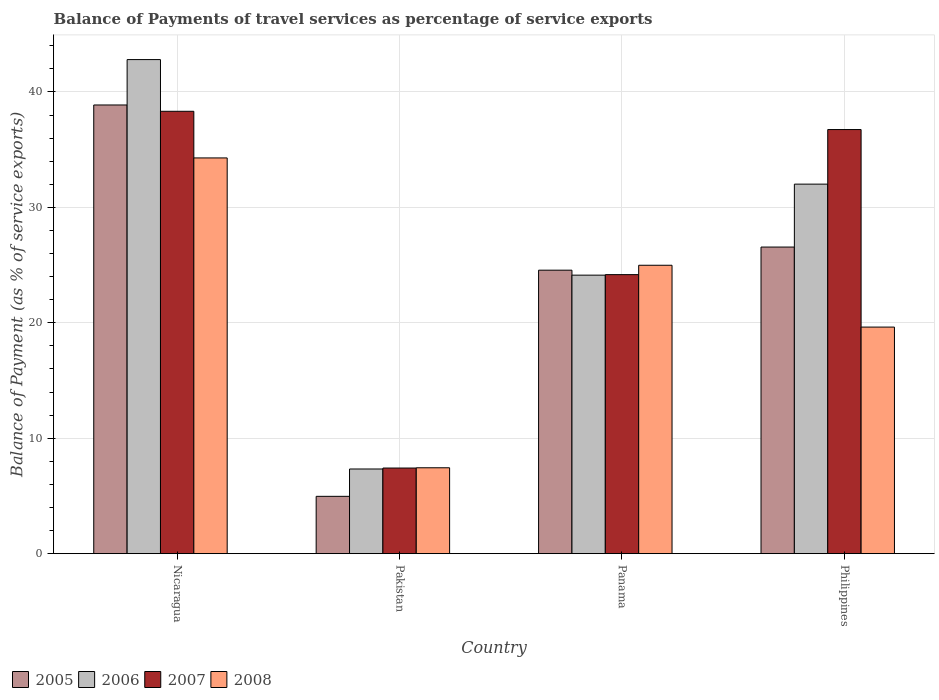How many groups of bars are there?
Keep it short and to the point. 4. Are the number of bars per tick equal to the number of legend labels?
Your answer should be very brief. Yes. Are the number of bars on each tick of the X-axis equal?
Your response must be concise. Yes. How many bars are there on the 4th tick from the right?
Provide a short and direct response. 4. What is the label of the 1st group of bars from the left?
Make the answer very short. Nicaragua. In how many cases, is the number of bars for a given country not equal to the number of legend labels?
Give a very brief answer. 0. What is the balance of payments of travel services in 2007 in Panama?
Offer a terse response. 24.18. Across all countries, what is the maximum balance of payments of travel services in 2005?
Provide a short and direct response. 38.87. Across all countries, what is the minimum balance of payments of travel services in 2005?
Make the answer very short. 4.97. In which country was the balance of payments of travel services in 2005 maximum?
Your answer should be compact. Nicaragua. In which country was the balance of payments of travel services in 2008 minimum?
Provide a short and direct response. Pakistan. What is the total balance of payments of travel services in 2007 in the graph?
Ensure brevity in your answer.  106.66. What is the difference between the balance of payments of travel services in 2008 in Nicaragua and that in Pakistan?
Give a very brief answer. 26.85. What is the difference between the balance of payments of travel services in 2006 in Pakistan and the balance of payments of travel services in 2008 in Philippines?
Keep it short and to the point. -12.29. What is the average balance of payments of travel services in 2008 per country?
Ensure brevity in your answer.  21.59. What is the difference between the balance of payments of travel services of/in 2005 and balance of payments of travel services of/in 2006 in Nicaragua?
Make the answer very short. -3.93. In how many countries, is the balance of payments of travel services in 2006 greater than 34 %?
Ensure brevity in your answer.  1. What is the ratio of the balance of payments of travel services in 2008 in Panama to that in Philippines?
Give a very brief answer. 1.27. Is the difference between the balance of payments of travel services in 2005 in Nicaragua and Pakistan greater than the difference between the balance of payments of travel services in 2006 in Nicaragua and Pakistan?
Make the answer very short. No. What is the difference between the highest and the second highest balance of payments of travel services in 2005?
Make the answer very short. -2. What is the difference between the highest and the lowest balance of payments of travel services in 2005?
Provide a short and direct response. 33.91. Is the sum of the balance of payments of travel services in 2007 in Nicaragua and Philippines greater than the maximum balance of payments of travel services in 2008 across all countries?
Your response must be concise. Yes. What does the 1st bar from the left in Nicaragua represents?
Your answer should be compact. 2005. What does the 3rd bar from the right in Nicaragua represents?
Your answer should be compact. 2006. Are all the bars in the graph horizontal?
Make the answer very short. No. How many countries are there in the graph?
Keep it short and to the point. 4. What is the difference between two consecutive major ticks on the Y-axis?
Provide a succinct answer. 10. Are the values on the major ticks of Y-axis written in scientific E-notation?
Offer a terse response. No. Does the graph contain any zero values?
Provide a short and direct response. No. Where does the legend appear in the graph?
Your response must be concise. Bottom left. How are the legend labels stacked?
Your answer should be very brief. Horizontal. What is the title of the graph?
Provide a succinct answer. Balance of Payments of travel services as percentage of service exports. Does "1974" appear as one of the legend labels in the graph?
Provide a short and direct response. No. What is the label or title of the X-axis?
Give a very brief answer. Country. What is the label or title of the Y-axis?
Provide a succinct answer. Balance of Payment (as % of service exports). What is the Balance of Payment (as % of service exports) of 2005 in Nicaragua?
Give a very brief answer. 38.87. What is the Balance of Payment (as % of service exports) in 2006 in Nicaragua?
Provide a short and direct response. 42.81. What is the Balance of Payment (as % of service exports) of 2007 in Nicaragua?
Your answer should be very brief. 38.33. What is the Balance of Payment (as % of service exports) in 2008 in Nicaragua?
Provide a succinct answer. 34.29. What is the Balance of Payment (as % of service exports) of 2005 in Pakistan?
Your answer should be compact. 4.97. What is the Balance of Payment (as % of service exports) of 2006 in Pakistan?
Your response must be concise. 7.34. What is the Balance of Payment (as % of service exports) in 2007 in Pakistan?
Your answer should be compact. 7.42. What is the Balance of Payment (as % of service exports) in 2008 in Pakistan?
Provide a succinct answer. 7.44. What is the Balance of Payment (as % of service exports) in 2005 in Panama?
Your response must be concise. 24.56. What is the Balance of Payment (as % of service exports) in 2006 in Panama?
Your answer should be compact. 24.13. What is the Balance of Payment (as % of service exports) of 2007 in Panama?
Provide a short and direct response. 24.18. What is the Balance of Payment (as % of service exports) of 2008 in Panama?
Ensure brevity in your answer.  24.99. What is the Balance of Payment (as % of service exports) in 2005 in Philippines?
Offer a terse response. 26.56. What is the Balance of Payment (as % of service exports) of 2006 in Philippines?
Offer a terse response. 32.02. What is the Balance of Payment (as % of service exports) of 2007 in Philippines?
Your answer should be compact. 36.74. What is the Balance of Payment (as % of service exports) in 2008 in Philippines?
Make the answer very short. 19.63. Across all countries, what is the maximum Balance of Payment (as % of service exports) in 2005?
Offer a very short reply. 38.87. Across all countries, what is the maximum Balance of Payment (as % of service exports) of 2006?
Offer a terse response. 42.81. Across all countries, what is the maximum Balance of Payment (as % of service exports) in 2007?
Ensure brevity in your answer.  38.33. Across all countries, what is the maximum Balance of Payment (as % of service exports) of 2008?
Give a very brief answer. 34.29. Across all countries, what is the minimum Balance of Payment (as % of service exports) of 2005?
Your answer should be very brief. 4.97. Across all countries, what is the minimum Balance of Payment (as % of service exports) of 2006?
Your answer should be compact. 7.34. Across all countries, what is the minimum Balance of Payment (as % of service exports) of 2007?
Keep it short and to the point. 7.42. Across all countries, what is the minimum Balance of Payment (as % of service exports) in 2008?
Make the answer very short. 7.44. What is the total Balance of Payment (as % of service exports) of 2005 in the graph?
Your response must be concise. 94.96. What is the total Balance of Payment (as % of service exports) in 2006 in the graph?
Make the answer very short. 106.29. What is the total Balance of Payment (as % of service exports) of 2007 in the graph?
Your response must be concise. 106.66. What is the total Balance of Payment (as % of service exports) of 2008 in the graph?
Offer a terse response. 86.34. What is the difference between the Balance of Payment (as % of service exports) of 2005 in Nicaragua and that in Pakistan?
Provide a short and direct response. 33.91. What is the difference between the Balance of Payment (as % of service exports) of 2006 in Nicaragua and that in Pakistan?
Make the answer very short. 35.47. What is the difference between the Balance of Payment (as % of service exports) of 2007 in Nicaragua and that in Pakistan?
Your answer should be compact. 30.91. What is the difference between the Balance of Payment (as % of service exports) in 2008 in Nicaragua and that in Pakistan?
Your answer should be compact. 26.85. What is the difference between the Balance of Payment (as % of service exports) of 2005 in Nicaragua and that in Panama?
Offer a very short reply. 14.31. What is the difference between the Balance of Payment (as % of service exports) of 2006 in Nicaragua and that in Panama?
Ensure brevity in your answer.  18.68. What is the difference between the Balance of Payment (as % of service exports) in 2007 in Nicaragua and that in Panama?
Ensure brevity in your answer.  14.15. What is the difference between the Balance of Payment (as % of service exports) in 2008 in Nicaragua and that in Panama?
Your answer should be very brief. 9.3. What is the difference between the Balance of Payment (as % of service exports) of 2005 in Nicaragua and that in Philippines?
Your answer should be compact. 12.31. What is the difference between the Balance of Payment (as % of service exports) in 2006 in Nicaragua and that in Philippines?
Provide a succinct answer. 10.79. What is the difference between the Balance of Payment (as % of service exports) of 2007 in Nicaragua and that in Philippines?
Make the answer very short. 1.58. What is the difference between the Balance of Payment (as % of service exports) in 2008 in Nicaragua and that in Philippines?
Offer a very short reply. 14.66. What is the difference between the Balance of Payment (as % of service exports) in 2005 in Pakistan and that in Panama?
Your answer should be very brief. -19.59. What is the difference between the Balance of Payment (as % of service exports) in 2006 in Pakistan and that in Panama?
Your answer should be compact. -16.79. What is the difference between the Balance of Payment (as % of service exports) of 2007 in Pakistan and that in Panama?
Provide a succinct answer. -16.76. What is the difference between the Balance of Payment (as % of service exports) of 2008 in Pakistan and that in Panama?
Provide a succinct answer. -17.55. What is the difference between the Balance of Payment (as % of service exports) of 2005 in Pakistan and that in Philippines?
Keep it short and to the point. -21.6. What is the difference between the Balance of Payment (as % of service exports) in 2006 in Pakistan and that in Philippines?
Your response must be concise. -24.68. What is the difference between the Balance of Payment (as % of service exports) of 2007 in Pakistan and that in Philippines?
Offer a terse response. -29.33. What is the difference between the Balance of Payment (as % of service exports) of 2008 in Pakistan and that in Philippines?
Your answer should be compact. -12.19. What is the difference between the Balance of Payment (as % of service exports) of 2005 in Panama and that in Philippines?
Your answer should be very brief. -2. What is the difference between the Balance of Payment (as % of service exports) in 2006 in Panama and that in Philippines?
Ensure brevity in your answer.  -7.88. What is the difference between the Balance of Payment (as % of service exports) in 2007 in Panama and that in Philippines?
Your response must be concise. -12.57. What is the difference between the Balance of Payment (as % of service exports) of 2008 in Panama and that in Philippines?
Provide a short and direct response. 5.36. What is the difference between the Balance of Payment (as % of service exports) in 2005 in Nicaragua and the Balance of Payment (as % of service exports) in 2006 in Pakistan?
Your answer should be very brief. 31.54. What is the difference between the Balance of Payment (as % of service exports) in 2005 in Nicaragua and the Balance of Payment (as % of service exports) in 2007 in Pakistan?
Keep it short and to the point. 31.46. What is the difference between the Balance of Payment (as % of service exports) of 2005 in Nicaragua and the Balance of Payment (as % of service exports) of 2008 in Pakistan?
Offer a terse response. 31.43. What is the difference between the Balance of Payment (as % of service exports) in 2006 in Nicaragua and the Balance of Payment (as % of service exports) in 2007 in Pakistan?
Give a very brief answer. 35.39. What is the difference between the Balance of Payment (as % of service exports) in 2006 in Nicaragua and the Balance of Payment (as % of service exports) in 2008 in Pakistan?
Give a very brief answer. 35.37. What is the difference between the Balance of Payment (as % of service exports) in 2007 in Nicaragua and the Balance of Payment (as % of service exports) in 2008 in Pakistan?
Provide a succinct answer. 30.89. What is the difference between the Balance of Payment (as % of service exports) of 2005 in Nicaragua and the Balance of Payment (as % of service exports) of 2006 in Panama?
Offer a very short reply. 14.74. What is the difference between the Balance of Payment (as % of service exports) of 2005 in Nicaragua and the Balance of Payment (as % of service exports) of 2007 in Panama?
Give a very brief answer. 14.7. What is the difference between the Balance of Payment (as % of service exports) in 2005 in Nicaragua and the Balance of Payment (as % of service exports) in 2008 in Panama?
Provide a short and direct response. 13.89. What is the difference between the Balance of Payment (as % of service exports) in 2006 in Nicaragua and the Balance of Payment (as % of service exports) in 2007 in Panama?
Ensure brevity in your answer.  18.63. What is the difference between the Balance of Payment (as % of service exports) of 2006 in Nicaragua and the Balance of Payment (as % of service exports) of 2008 in Panama?
Provide a succinct answer. 17.82. What is the difference between the Balance of Payment (as % of service exports) of 2007 in Nicaragua and the Balance of Payment (as % of service exports) of 2008 in Panama?
Offer a terse response. 13.34. What is the difference between the Balance of Payment (as % of service exports) in 2005 in Nicaragua and the Balance of Payment (as % of service exports) in 2006 in Philippines?
Provide a short and direct response. 6.86. What is the difference between the Balance of Payment (as % of service exports) of 2005 in Nicaragua and the Balance of Payment (as % of service exports) of 2007 in Philippines?
Keep it short and to the point. 2.13. What is the difference between the Balance of Payment (as % of service exports) in 2005 in Nicaragua and the Balance of Payment (as % of service exports) in 2008 in Philippines?
Give a very brief answer. 19.24. What is the difference between the Balance of Payment (as % of service exports) in 2006 in Nicaragua and the Balance of Payment (as % of service exports) in 2007 in Philippines?
Give a very brief answer. 6.06. What is the difference between the Balance of Payment (as % of service exports) in 2006 in Nicaragua and the Balance of Payment (as % of service exports) in 2008 in Philippines?
Provide a short and direct response. 23.18. What is the difference between the Balance of Payment (as % of service exports) of 2007 in Nicaragua and the Balance of Payment (as % of service exports) of 2008 in Philippines?
Provide a succinct answer. 18.7. What is the difference between the Balance of Payment (as % of service exports) in 2005 in Pakistan and the Balance of Payment (as % of service exports) in 2006 in Panama?
Your response must be concise. -19.16. What is the difference between the Balance of Payment (as % of service exports) of 2005 in Pakistan and the Balance of Payment (as % of service exports) of 2007 in Panama?
Make the answer very short. -19.21. What is the difference between the Balance of Payment (as % of service exports) in 2005 in Pakistan and the Balance of Payment (as % of service exports) in 2008 in Panama?
Provide a succinct answer. -20.02. What is the difference between the Balance of Payment (as % of service exports) of 2006 in Pakistan and the Balance of Payment (as % of service exports) of 2007 in Panama?
Offer a very short reply. -16.84. What is the difference between the Balance of Payment (as % of service exports) in 2006 in Pakistan and the Balance of Payment (as % of service exports) in 2008 in Panama?
Your response must be concise. -17.65. What is the difference between the Balance of Payment (as % of service exports) in 2007 in Pakistan and the Balance of Payment (as % of service exports) in 2008 in Panama?
Offer a terse response. -17.57. What is the difference between the Balance of Payment (as % of service exports) of 2005 in Pakistan and the Balance of Payment (as % of service exports) of 2006 in Philippines?
Your response must be concise. -27.05. What is the difference between the Balance of Payment (as % of service exports) of 2005 in Pakistan and the Balance of Payment (as % of service exports) of 2007 in Philippines?
Offer a very short reply. -31.78. What is the difference between the Balance of Payment (as % of service exports) of 2005 in Pakistan and the Balance of Payment (as % of service exports) of 2008 in Philippines?
Offer a terse response. -14.66. What is the difference between the Balance of Payment (as % of service exports) in 2006 in Pakistan and the Balance of Payment (as % of service exports) in 2007 in Philippines?
Make the answer very short. -29.41. What is the difference between the Balance of Payment (as % of service exports) in 2006 in Pakistan and the Balance of Payment (as % of service exports) in 2008 in Philippines?
Offer a very short reply. -12.29. What is the difference between the Balance of Payment (as % of service exports) in 2007 in Pakistan and the Balance of Payment (as % of service exports) in 2008 in Philippines?
Make the answer very short. -12.21. What is the difference between the Balance of Payment (as % of service exports) of 2005 in Panama and the Balance of Payment (as % of service exports) of 2006 in Philippines?
Provide a succinct answer. -7.46. What is the difference between the Balance of Payment (as % of service exports) of 2005 in Panama and the Balance of Payment (as % of service exports) of 2007 in Philippines?
Your response must be concise. -12.18. What is the difference between the Balance of Payment (as % of service exports) of 2005 in Panama and the Balance of Payment (as % of service exports) of 2008 in Philippines?
Keep it short and to the point. 4.93. What is the difference between the Balance of Payment (as % of service exports) in 2006 in Panama and the Balance of Payment (as % of service exports) in 2007 in Philippines?
Provide a short and direct response. -12.61. What is the difference between the Balance of Payment (as % of service exports) in 2006 in Panama and the Balance of Payment (as % of service exports) in 2008 in Philippines?
Offer a terse response. 4.5. What is the difference between the Balance of Payment (as % of service exports) in 2007 in Panama and the Balance of Payment (as % of service exports) in 2008 in Philippines?
Make the answer very short. 4.55. What is the average Balance of Payment (as % of service exports) of 2005 per country?
Give a very brief answer. 23.74. What is the average Balance of Payment (as % of service exports) of 2006 per country?
Offer a terse response. 26.57. What is the average Balance of Payment (as % of service exports) of 2007 per country?
Your answer should be compact. 26.67. What is the average Balance of Payment (as % of service exports) in 2008 per country?
Your response must be concise. 21.59. What is the difference between the Balance of Payment (as % of service exports) of 2005 and Balance of Payment (as % of service exports) of 2006 in Nicaragua?
Provide a short and direct response. -3.93. What is the difference between the Balance of Payment (as % of service exports) in 2005 and Balance of Payment (as % of service exports) in 2007 in Nicaragua?
Make the answer very short. 0.55. What is the difference between the Balance of Payment (as % of service exports) of 2005 and Balance of Payment (as % of service exports) of 2008 in Nicaragua?
Ensure brevity in your answer.  4.59. What is the difference between the Balance of Payment (as % of service exports) in 2006 and Balance of Payment (as % of service exports) in 2007 in Nicaragua?
Ensure brevity in your answer.  4.48. What is the difference between the Balance of Payment (as % of service exports) of 2006 and Balance of Payment (as % of service exports) of 2008 in Nicaragua?
Your answer should be compact. 8.52. What is the difference between the Balance of Payment (as % of service exports) of 2007 and Balance of Payment (as % of service exports) of 2008 in Nicaragua?
Make the answer very short. 4.04. What is the difference between the Balance of Payment (as % of service exports) of 2005 and Balance of Payment (as % of service exports) of 2006 in Pakistan?
Provide a succinct answer. -2.37. What is the difference between the Balance of Payment (as % of service exports) of 2005 and Balance of Payment (as % of service exports) of 2007 in Pakistan?
Offer a very short reply. -2.45. What is the difference between the Balance of Payment (as % of service exports) in 2005 and Balance of Payment (as % of service exports) in 2008 in Pakistan?
Offer a terse response. -2.47. What is the difference between the Balance of Payment (as % of service exports) of 2006 and Balance of Payment (as % of service exports) of 2007 in Pakistan?
Offer a terse response. -0.08. What is the difference between the Balance of Payment (as % of service exports) of 2006 and Balance of Payment (as % of service exports) of 2008 in Pakistan?
Your answer should be very brief. -0.1. What is the difference between the Balance of Payment (as % of service exports) of 2007 and Balance of Payment (as % of service exports) of 2008 in Pakistan?
Offer a very short reply. -0.02. What is the difference between the Balance of Payment (as % of service exports) in 2005 and Balance of Payment (as % of service exports) in 2006 in Panama?
Give a very brief answer. 0.43. What is the difference between the Balance of Payment (as % of service exports) of 2005 and Balance of Payment (as % of service exports) of 2007 in Panama?
Your response must be concise. 0.38. What is the difference between the Balance of Payment (as % of service exports) in 2005 and Balance of Payment (as % of service exports) in 2008 in Panama?
Your response must be concise. -0.43. What is the difference between the Balance of Payment (as % of service exports) in 2006 and Balance of Payment (as % of service exports) in 2007 in Panama?
Offer a terse response. -0.04. What is the difference between the Balance of Payment (as % of service exports) of 2006 and Balance of Payment (as % of service exports) of 2008 in Panama?
Give a very brief answer. -0.86. What is the difference between the Balance of Payment (as % of service exports) of 2007 and Balance of Payment (as % of service exports) of 2008 in Panama?
Offer a very short reply. -0.81. What is the difference between the Balance of Payment (as % of service exports) of 2005 and Balance of Payment (as % of service exports) of 2006 in Philippines?
Ensure brevity in your answer.  -5.45. What is the difference between the Balance of Payment (as % of service exports) of 2005 and Balance of Payment (as % of service exports) of 2007 in Philippines?
Offer a terse response. -10.18. What is the difference between the Balance of Payment (as % of service exports) in 2005 and Balance of Payment (as % of service exports) in 2008 in Philippines?
Give a very brief answer. 6.93. What is the difference between the Balance of Payment (as % of service exports) of 2006 and Balance of Payment (as % of service exports) of 2007 in Philippines?
Offer a terse response. -4.73. What is the difference between the Balance of Payment (as % of service exports) in 2006 and Balance of Payment (as % of service exports) in 2008 in Philippines?
Keep it short and to the point. 12.39. What is the difference between the Balance of Payment (as % of service exports) in 2007 and Balance of Payment (as % of service exports) in 2008 in Philippines?
Offer a very short reply. 17.11. What is the ratio of the Balance of Payment (as % of service exports) in 2005 in Nicaragua to that in Pakistan?
Your response must be concise. 7.83. What is the ratio of the Balance of Payment (as % of service exports) of 2006 in Nicaragua to that in Pakistan?
Ensure brevity in your answer.  5.84. What is the ratio of the Balance of Payment (as % of service exports) in 2007 in Nicaragua to that in Pakistan?
Keep it short and to the point. 5.17. What is the ratio of the Balance of Payment (as % of service exports) of 2008 in Nicaragua to that in Pakistan?
Make the answer very short. 4.61. What is the ratio of the Balance of Payment (as % of service exports) in 2005 in Nicaragua to that in Panama?
Your answer should be very brief. 1.58. What is the ratio of the Balance of Payment (as % of service exports) of 2006 in Nicaragua to that in Panama?
Your answer should be very brief. 1.77. What is the ratio of the Balance of Payment (as % of service exports) in 2007 in Nicaragua to that in Panama?
Make the answer very short. 1.59. What is the ratio of the Balance of Payment (as % of service exports) of 2008 in Nicaragua to that in Panama?
Provide a short and direct response. 1.37. What is the ratio of the Balance of Payment (as % of service exports) of 2005 in Nicaragua to that in Philippines?
Provide a short and direct response. 1.46. What is the ratio of the Balance of Payment (as % of service exports) in 2006 in Nicaragua to that in Philippines?
Provide a succinct answer. 1.34. What is the ratio of the Balance of Payment (as % of service exports) in 2007 in Nicaragua to that in Philippines?
Offer a very short reply. 1.04. What is the ratio of the Balance of Payment (as % of service exports) of 2008 in Nicaragua to that in Philippines?
Your response must be concise. 1.75. What is the ratio of the Balance of Payment (as % of service exports) of 2005 in Pakistan to that in Panama?
Provide a succinct answer. 0.2. What is the ratio of the Balance of Payment (as % of service exports) of 2006 in Pakistan to that in Panama?
Offer a terse response. 0.3. What is the ratio of the Balance of Payment (as % of service exports) of 2007 in Pakistan to that in Panama?
Your answer should be compact. 0.31. What is the ratio of the Balance of Payment (as % of service exports) of 2008 in Pakistan to that in Panama?
Ensure brevity in your answer.  0.3. What is the ratio of the Balance of Payment (as % of service exports) in 2005 in Pakistan to that in Philippines?
Your answer should be compact. 0.19. What is the ratio of the Balance of Payment (as % of service exports) in 2006 in Pakistan to that in Philippines?
Your answer should be very brief. 0.23. What is the ratio of the Balance of Payment (as % of service exports) of 2007 in Pakistan to that in Philippines?
Offer a very short reply. 0.2. What is the ratio of the Balance of Payment (as % of service exports) in 2008 in Pakistan to that in Philippines?
Your answer should be compact. 0.38. What is the ratio of the Balance of Payment (as % of service exports) of 2005 in Panama to that in Philippines?
Provide a succinct answer. 0.92. What is the ratio of the Balance of Payment (as % of service exports) in 2006 in Panama to that in Philippines?
Your response must be concise. 0.75. What is the ratio of the Balance of Payment (as % of service exports) in 2007 in Panama to that in Philippines?
Your answer should be compact. 0.66. What is the ratio of the Balance of Payment (as % of service exports) of 2008 in Panama to that in Philippines?
Your answer should be very brief. 1.27. What is the difference between the highest and the second highest Balance of Payment (as % of service exports) of 2005?
Offer a terse response. 12.31. What is the difference between the highest and the second highest Balance of Payment (as % of service exports) of 2006?
Make the answer very short. 10.79. What is the difference between the highest and the second highest Balance of Payment (as % of service exports) in 2007?
Your answer should be compact. 1.58. What is the difference between the highest and the second highest Balance of Payment (as % of service exports) in 2008?
Give a very brief answer. 9.3. What is the difference between the highest and the lowest Balance of Payment (as % of service exports) in 2005?
Provide a succinct answer. 33.91. What is the difference between the highest and the lowest Balance of Payment (as % of service exports) of 2006?
Your response must be concise. 35.47. What is the difference between the highest and the lowest Balance of Payment (as % of service exports) of 2007?
Your answer should be very brief. 30.91. What is the difference between the highest and the lowest Balance of Payment (as % of service exports) of 2008?
Ensure brevity in your answer.  26.85. 